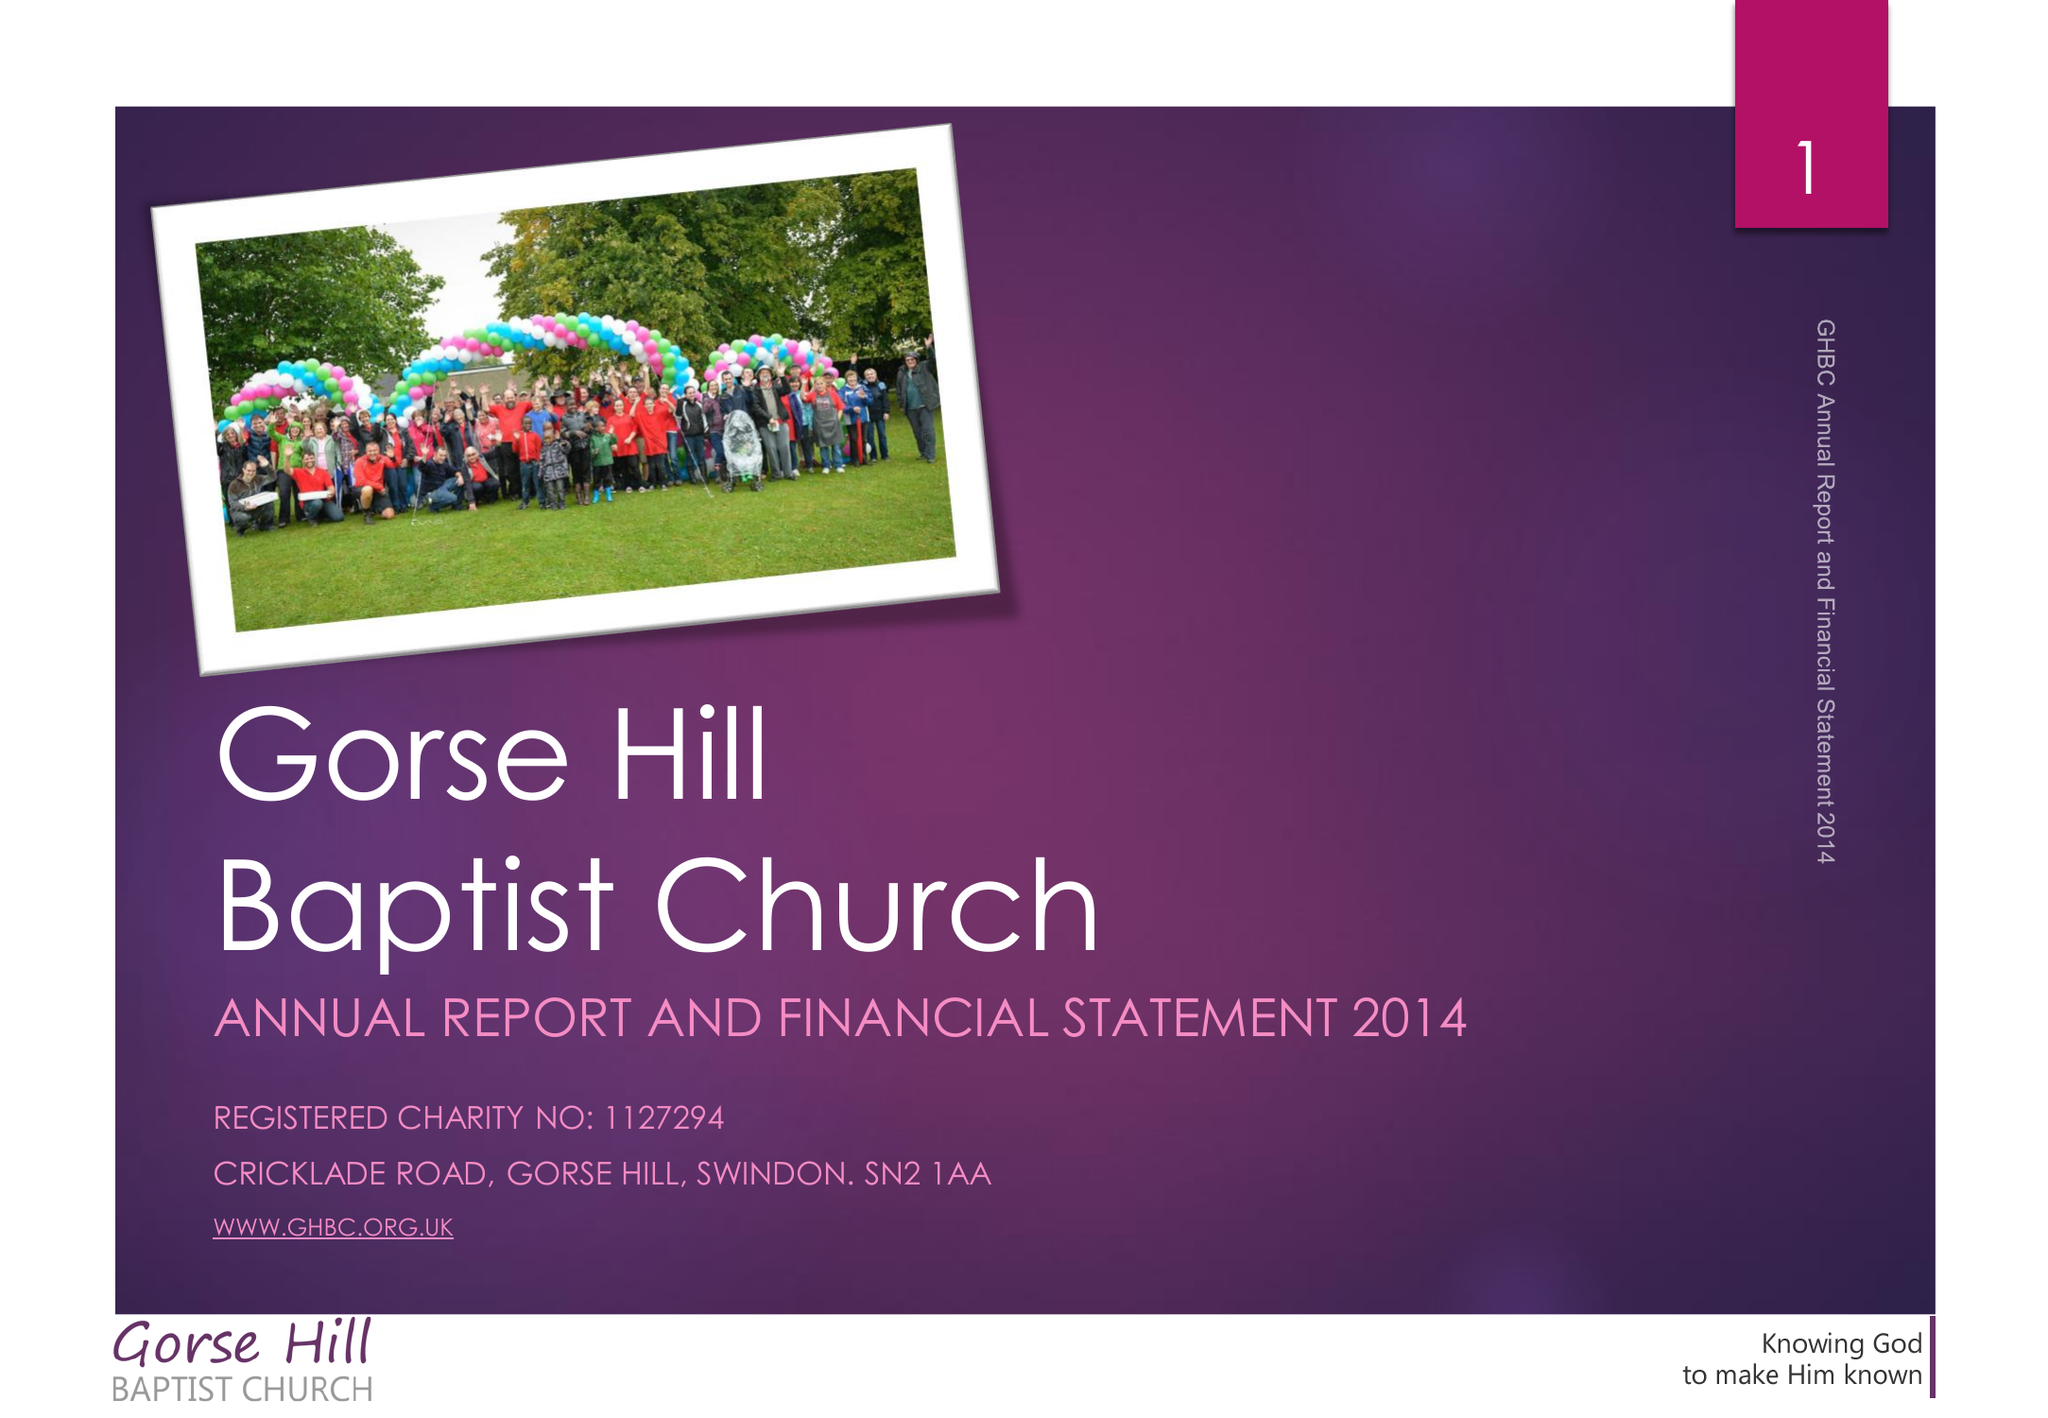What is the value for the address__street_line?
Answer the question using a single word or phrase. CRICKLADE ROAD 